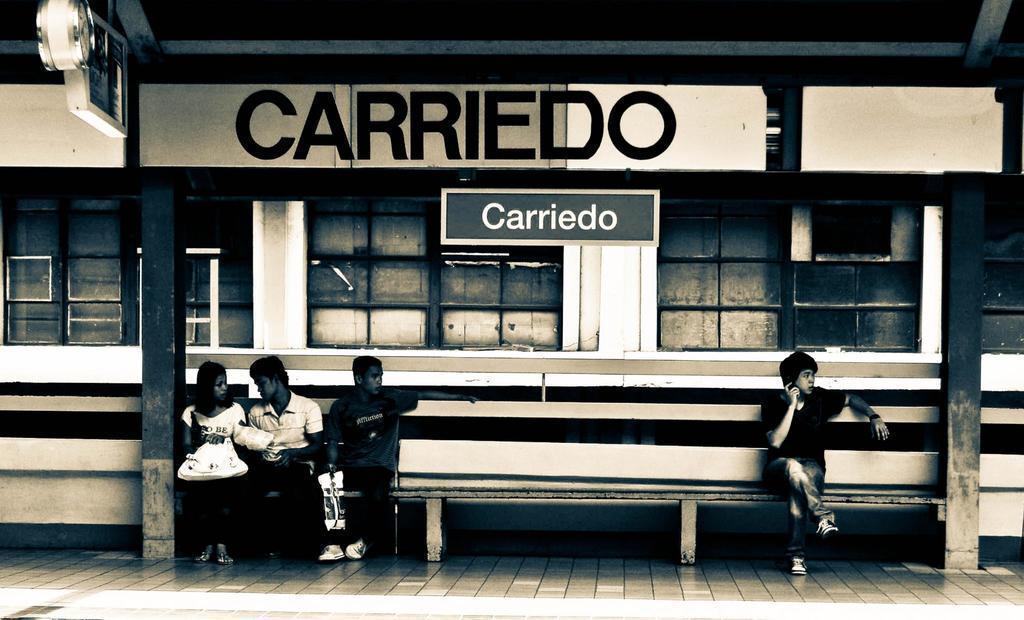How would you summarize this image in a sentence or two? In this image, we can see persons wearing clothes and sitting on the bench in front of the building. There is a pole on the left and on the right side of the image. 